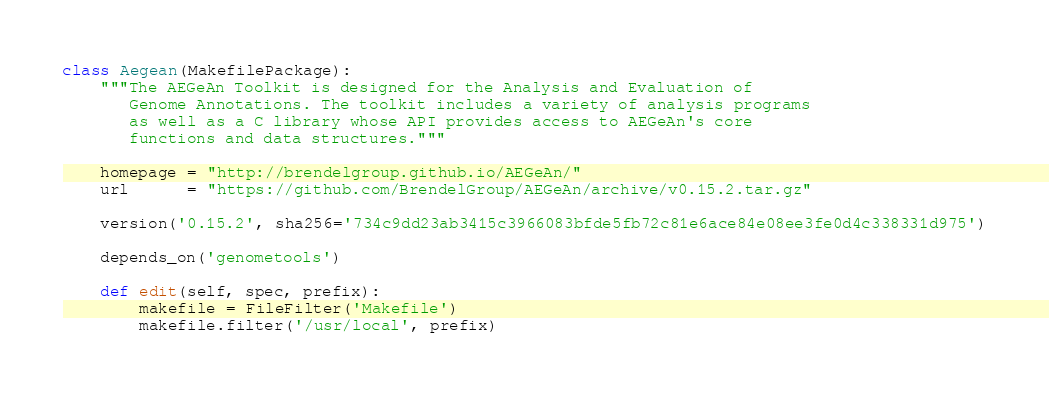<code> <loc_0><loc_0><loc_500><loc_500><_Python_>class Aegean(MakefilePackage):
    """The AEGeAn Toolkit is designed for the Analysis and Evaluation of
       Genome Annotations. The toolkit includes a variety of analysis programs
       as well as a C library whose API provides access to AEGeAn's core
       functions and data structures."""

    homepage = "http://brendelgroup.github.io/AEGeAn/"
    url      = "https://github.com/BrendelGroup/AEGeAn/archive/v0.15.2.tar.gz"

    version('0.15.2', sha256='734c9dd23ab3415c3966083bfde5fb72c81e6ace84e08ee3fe0d4c338331d975')

    depends_on('genometools')

    def edit(self, spec, prefix):
        makefile = FileFilter('Makefile')
        makefile.filter('/usr/local', prefix)
</code> 